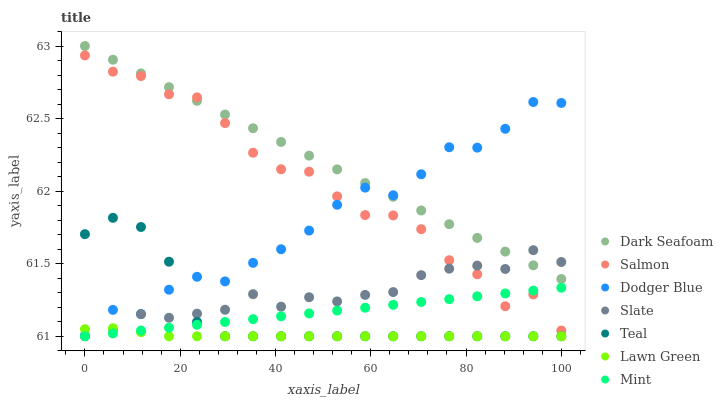Does Lawn Green have the minimum area under the curve?
Answer yes or no. Yes. Does Dark Seafoam have the maximum area under the curve?
Answer yes or no. Yes. Does Slate have the minimum area under the curve?
Answer yes or no. No. Does Slate have the maximum area under the curve?
Answer yes or no. No. Is Mint the smoothest?
Answer yes or no. Yes. Is Salmon the roughest?
Answer yes or no. Yes. Is Slate the smoothest?
Answer yes or no. No. Is Slate the roughest?
Answer yes or no. No. Does Lawn Green have the lowest value?
Answer yes or no. Yes. Does Salmon have the lowest value?
Answer yes or no. No. Does Dark Seafoam have the highest value?
Answer yes or no. Yes. Does Slate have the highest value?
Answer yes or no. No. Is Lawn Green less than Dark Seafoam?
Answer yes or no. Yes. Is Salmon greater than Teal?
Answer yes or no. Yes. Does Mint intersect Teal?
Answer yes or no. Yes. Is Mint less than Teal?
Answer yes or no. No. Is Mint greater than Teal?
Answer yes or no. No. Does Lawn Green intersect Dark Seafoam?
Answer yes or no. No. 